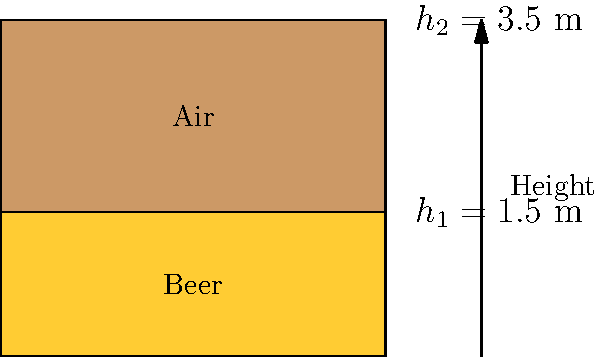You're tapping into your knowledge of fluid dynamics to solve a pressing issue at your bar. The pressure at the bottom of a beer keg is 120 kPa when it's full. If the keg is 3.5 m tall and the beer level drops to 1.5 m, what's the new pressure at the bottom? Assume the density of beer is 1000 kg/m³ and the acceleration due to gravity is 9.8 m/s². Don't let the answer fall flat! Let's tackle this step by step:

1) First, we need to understand that the pressure at the bottom of the keg is the sum of the atmospheric pressure and the pressure due to the beer column.

2) The pressure due to the beer column is given by the formula:
   $$P = \rho gh$$
   where $\rho$ is the density of beer, $g$ is the acceleration due to gravity, and $h$ is the height of the beer column.

3) When the keg is full:
   $P_{full} = P_{atm} + \rho gh_2 = 120$ kPa
   where $h_2 = 3.5$ m

4) We can calculate the atmospheric pressure:
   $P_{atm} = 120000 - (1000 \times 9.8 \times 3.5) = 85700$ Pa or 85.7 kPa

5) Now, when the beer level drops to 1.5 m:
   $P_{new} = P_{atm} + \rho gh_1$
   $P_{new} = 85700 + (1000 \times 9.8 \times 1.5)$
   $P_{new} = 85700 + 14700 = 100400$ Pa or 100.4 kPa

6) Rounding to the nearest kPa:
   $P_{new} \approx 100$ kPa
Answer: 100 kPa 